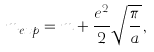<formula> <loc_0><loc_0><loc_500><loc_500>m _ { e x p } = m + \frac { e ^ { 2 } } { 2 } \sqrt { \frac { \pi } { a } } \, ,</formula> 